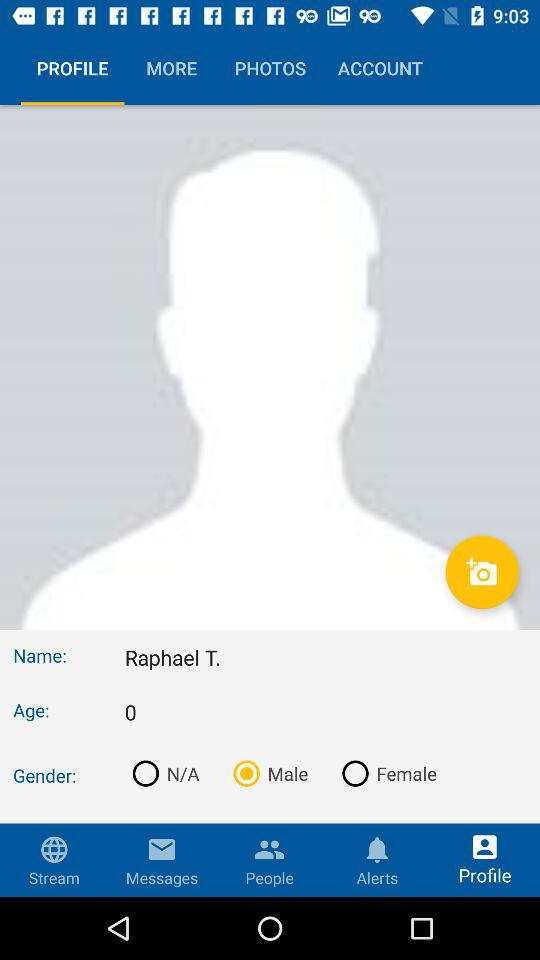What is the selected gender? The selected gender is "Male". 